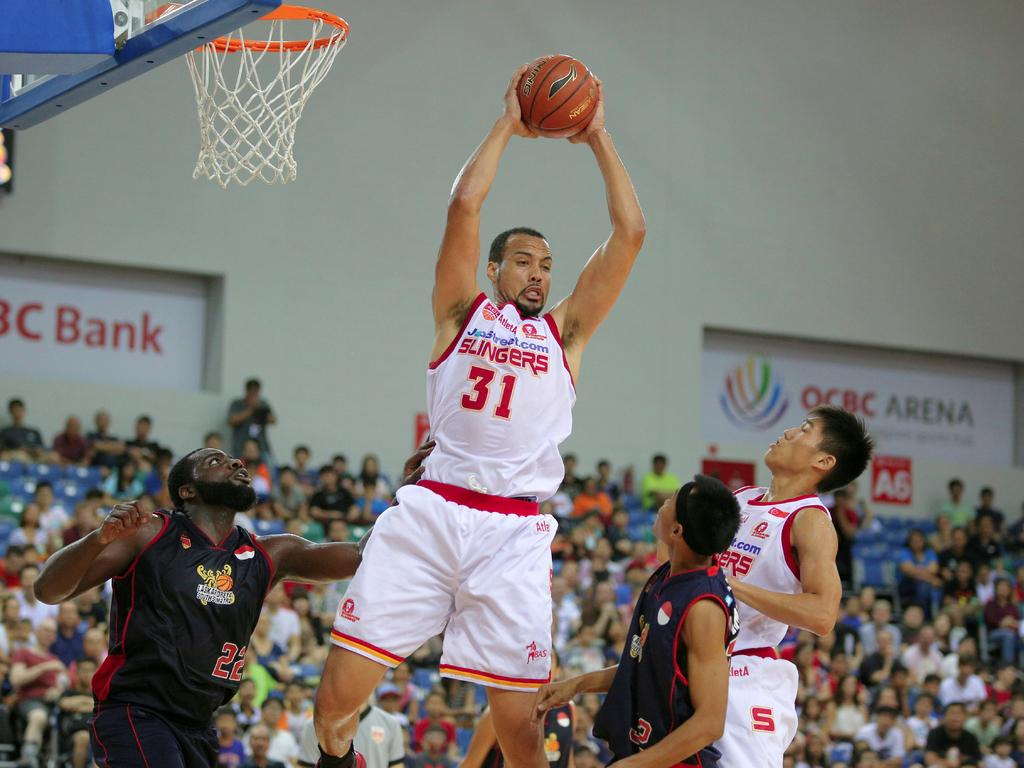<image>
Describe the image concisely. A basketball player wearing number 31 gets a rebound 